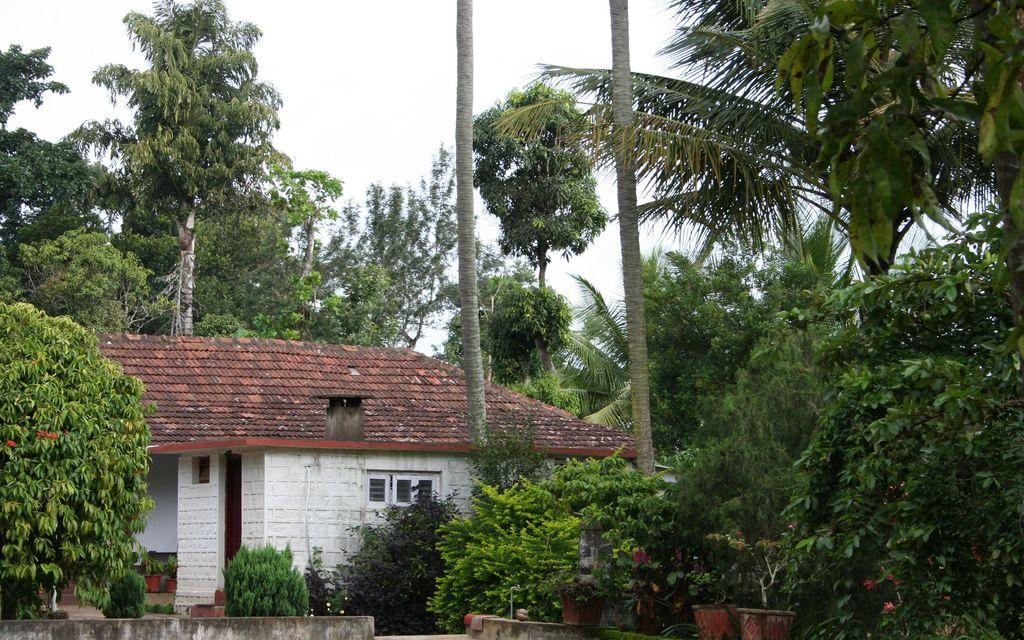What is the main subject of the image? The main subject of the image is a house. What is located in front of the house? There are plants in front of the house. What can be seen in the background of the image? There are trees and the sky visible in the background of the image. How does the house compare to the memory of the house from your childhood? The image does not contain any information about your childhood or any memories related to the house, so it cannot be compared to a memory. 